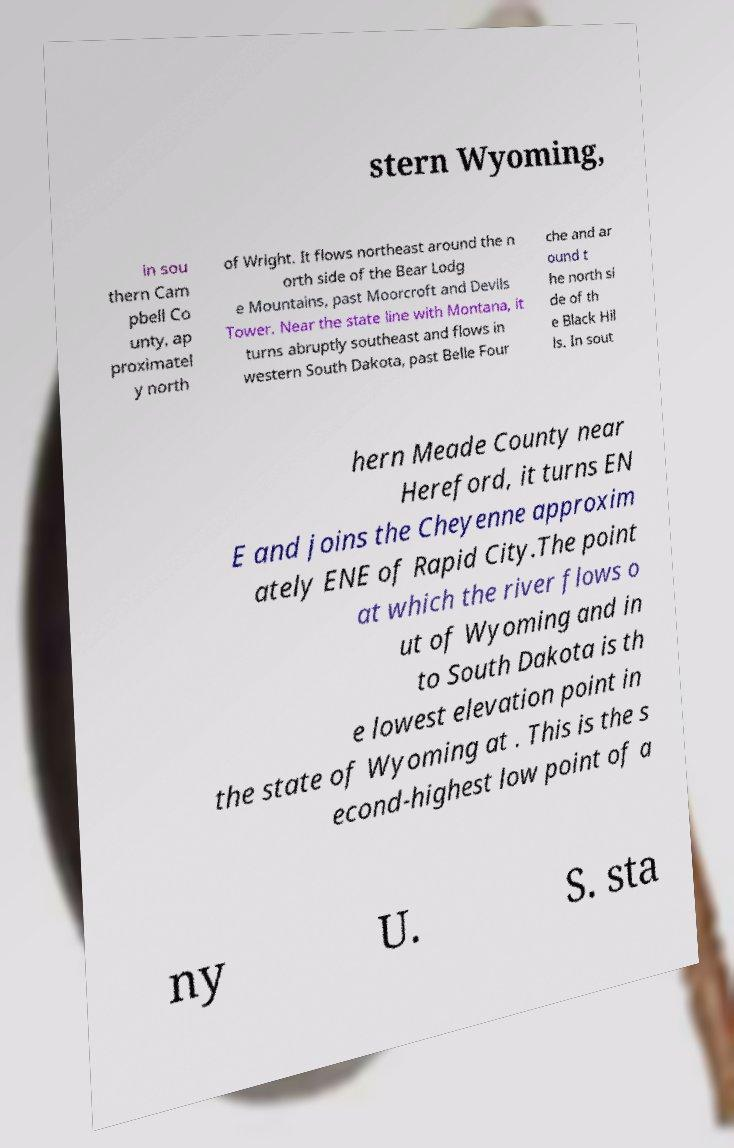There's text embedded in this image that I need extracted. Can you transcribe it verbatim? stern Wyoming, in sou thern Cam pbell Co unty, ap proximatel y north of Wright. It flows northeast around the n orth side of the Bear Lodg e Mountains, past Moorcroft and Devils Tower. Near the state line with Montana, it turns abruptly southeast and flows in western South Dakota, past Belle Four che and ar ound t he north si de of th e Black Hil ls. In sout hern Meade County near Hereford, it turns EN E and joins the Cheyenne approxim ately ENE of Rapid City.The point at which the river flows o ut of Wyoming and in to South Dakota is th e lowest elevation point in the state of Wyoming at . This is the s econd-highest low point of a ny U. S. sta 